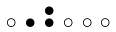<formula> <loc_0><loc_0><loc_500><loc_500>\begin{smallmatrix} & & \bullet \\ \circ & \bullet & \bullet & \circ & \circ & \circ & \\ \end{smallmatrix}</formula> 